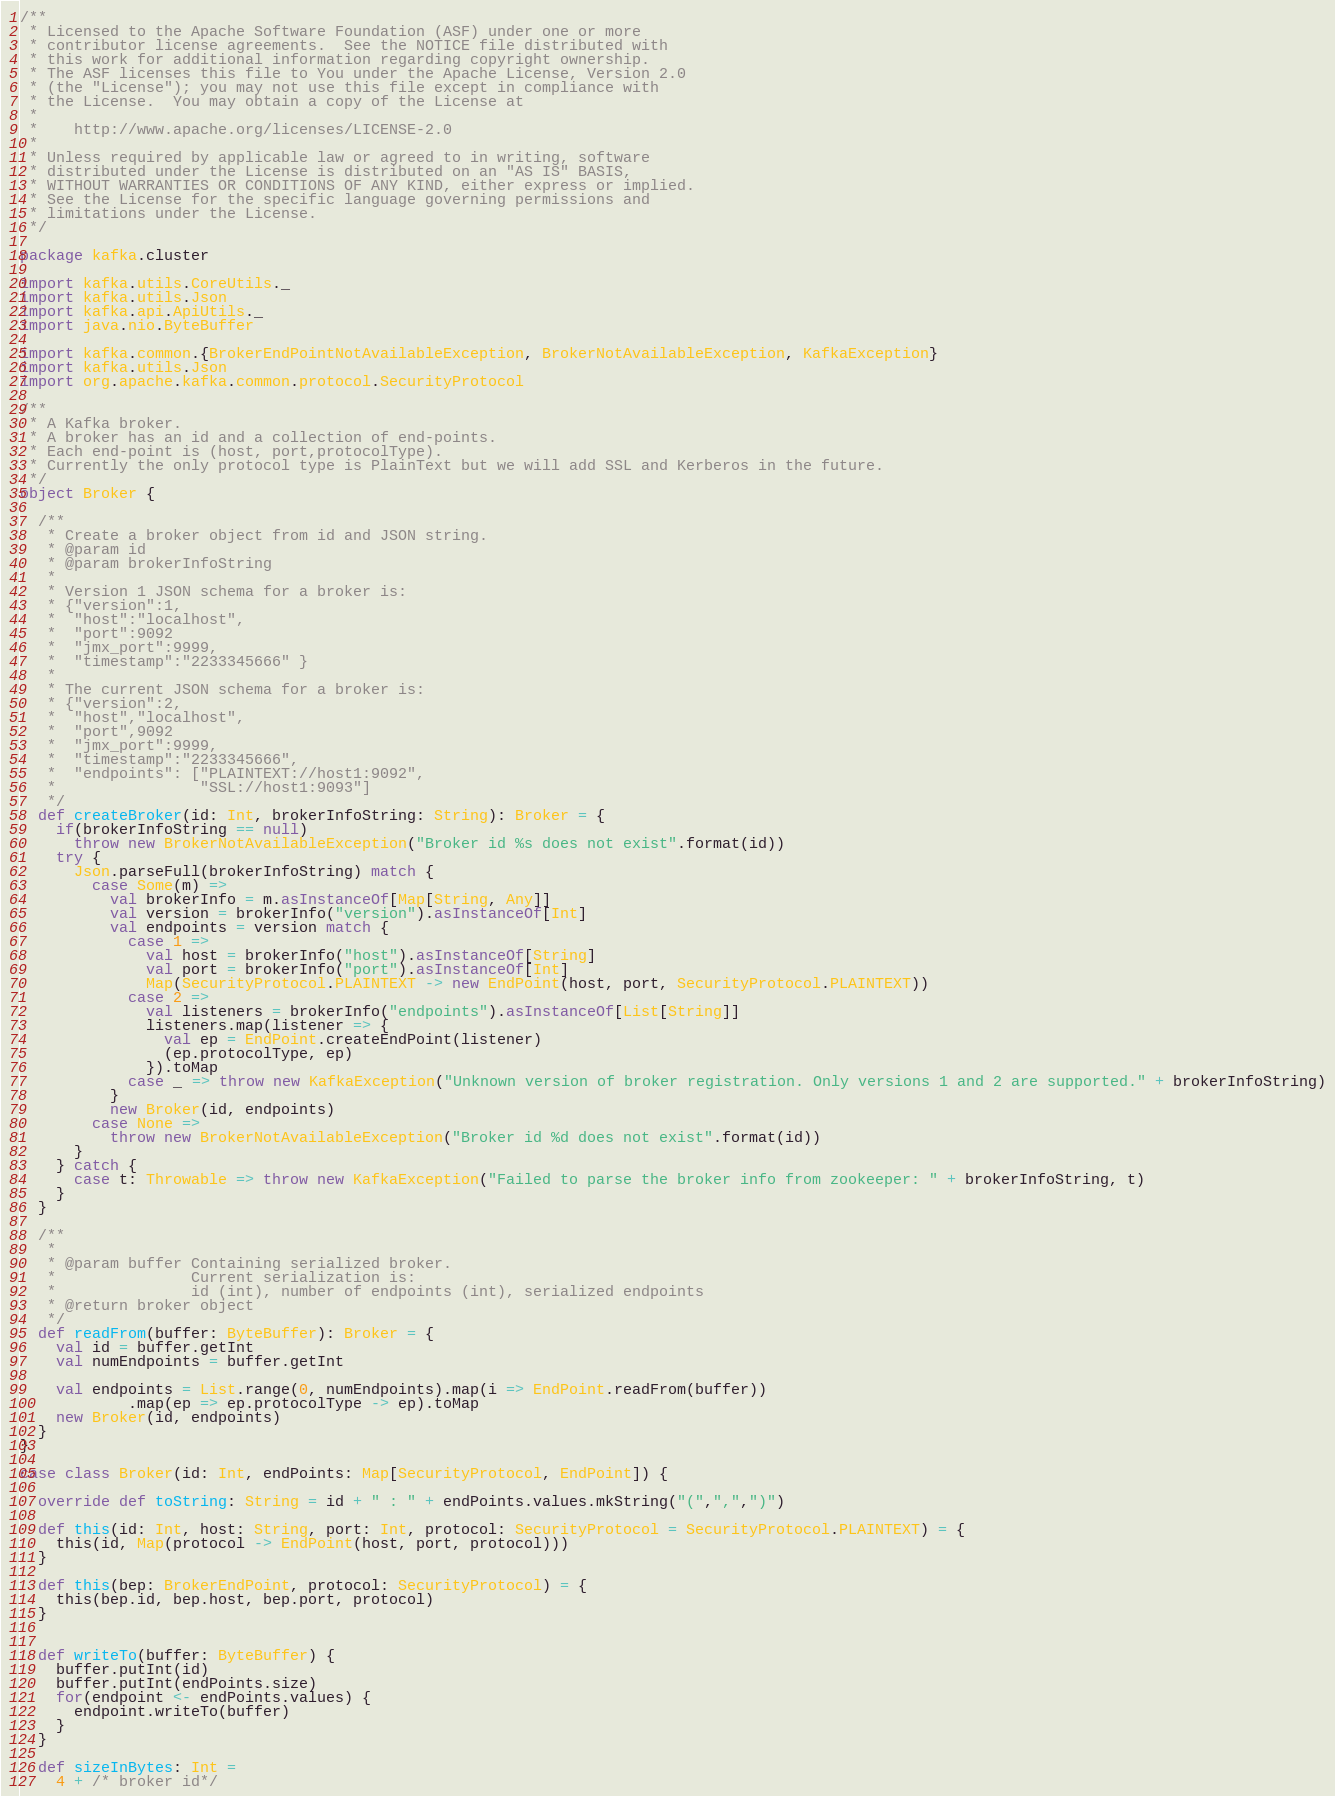Convert code to text. <code><loc_0><loc_0><loc_500><loc_500><_Scala_>/**
 * Licensed to the Apache Software Foundation (ASF) under one or more
 * contributor license agreements.  See the NOTICE file distributed with
 * this work for additional information regarding copyright ownership.
 * The ASF licenses this file to You under the Apache License, Version 2.0
 * (the "License"); you may not use this file except in compliance with
 * the License.  You may obtain a copy of the License at
 * 
 *    http://www.apache.org/licenses/LICENSE-2.0
 *
 * Unless required by applicable law or agreed to in writing, software
 * distributed under the License is distributed on an "AS IS" BASIS,
 * WITHOUT WARRANTIES OR CONDITIONS OF ANY KIND, either express or implied.
 * See the License for the specific language governing permissions and
 * limitations under the License.
 */

package kafka.cluster

import kafka.utils.CoreUtils._
import kafka.utils.Json
import kafka.api.ApiUtils._
import java.nio.ByteBuffer

import kafka.common.{BrokerEndPointNotAvailableException, BrokerNotAvailableException, KafkaException}
import kafka.utils.Json
import org.apache.kafka.common.protocol.SecurityProtocol

/**
 * A Kafka broker.
 * A broker has an id and a collection of end-points.
 * Each end-point is (host, port,protocolType).
 * Currently the only protocol type is PlainText but we will add SSL and Kerberos in the future.
 */
object Broker {

  /**
   * Create a broker object from id and JSON string.
   * @param id
   * @param brokerInfoString
   *
   * Version 1 JSON schema for a broker is:
   * {"version":1,
   *  "host":"localhost",
   *  "port":9092
   *  "jmx_port":9999,
   *  "timestamp":"2233345666" }
   *
   * The current JSON schema for a broker is:
   * {"version":2,
   *  "host","localhost",
   *  "port",9092
   *  "jmx_port":9999,
   *  "timestamp":"2233345666",
   *  "endpoints": ["PLAINTEXT://host1:9092",
   *                "SSL://host1:9093"]
   */
  def createBroker(id: Int, brokerInfoString: String): Broker = {
    if(brokerInfoString == null)
      throw new BrokerNotAvailableException("Broker id %s does not exist".format(id))
    try {
      Json.parseFull(brokerInfoString) match {
        case Some(m) =>
          val brokerInfo = m.asInstanceOf[Map[String, Any]]
          val version = brokerInfo("version").asInstanceOf[Int]
          val endpoints = version match {
            case 1 =>
              val host = brokerInfo("host").asInstanceOf[String]
              val port = brokerInfo("port").asInstanceOf[Int]
              Map(SecurityProtocol.PLAINTEXT -> new EndPoint(host, port, SecurityProtocol.PLAINTEXT))
            case 2 =>
              val listeners = brokerInfo("endpoints").asInstanceOf[List[String]]
              listeners.map(listener => {
                val ep = EndPoint.createEndPoint(listener)
                (ep.protocolType, ep)
              }).toMap
            case _ => throw new KafkaException("Unknown version of broker registration. Only versions 1 and 2 are supported." + brokerInfoString)
          }
          new Broker(id, endpoints)
        case None =>
          throw new BrokerNotAvailableException("Broker id %d does not exist".format(id))
      }
    } catch {
      case t: Throwable => throw new KafkaException("Failed to parse the broker info from zookeeper: " + brokerInfoString, t)
    }
  }

  /**
   *
   * @param buffer Containing serialized broker.
   *               Current serialization is:
   *               id (int), number of endpoints (int), serialized endpoints
   * @return broker object
   */
  def readFrom(buffer: ByteBuffer): Broker = {
    val id = buffer.getInt
    val numEndpoints = buffer.getInt

    val endpoints = List.range(0, numEndpoints).map(i => EndPoint.readFrom(buffer))
            .map(ep => ep.protocolType -> ep).toMap
    new Broker(id, endpoints)
  }
}

case class Broker(id: Int, endPoints: Map[SecurityProtocol, EndPoint]) {

  override def toString: String = id + " : " + endPoints.values.mkString("(",",",")")

  def this(id: Int, host: String, port: Int, protocol: SecurityProtocol = SecurityProtocol.PLAINTEXT) = {
    this(id, Map(protocol -> EndPoint(host, port, protocol)))
  }

  def this(bep: BrokerEndPoint, protocol: SecurityProtocol) = {
    this(bep.id, bep.host, bep.port, protocol)
  }


  def writeTo(buffer: ByteBuffer) {
    buffer.putInt(id)
    buffer.putInt(endPoints.size)
    for(endpoint <- endPoints.values) {
      endpoint.writeTo(buffer)
    }
  }

  def sizeInBytes: Int =
    4 + /* broker id*/</code> 